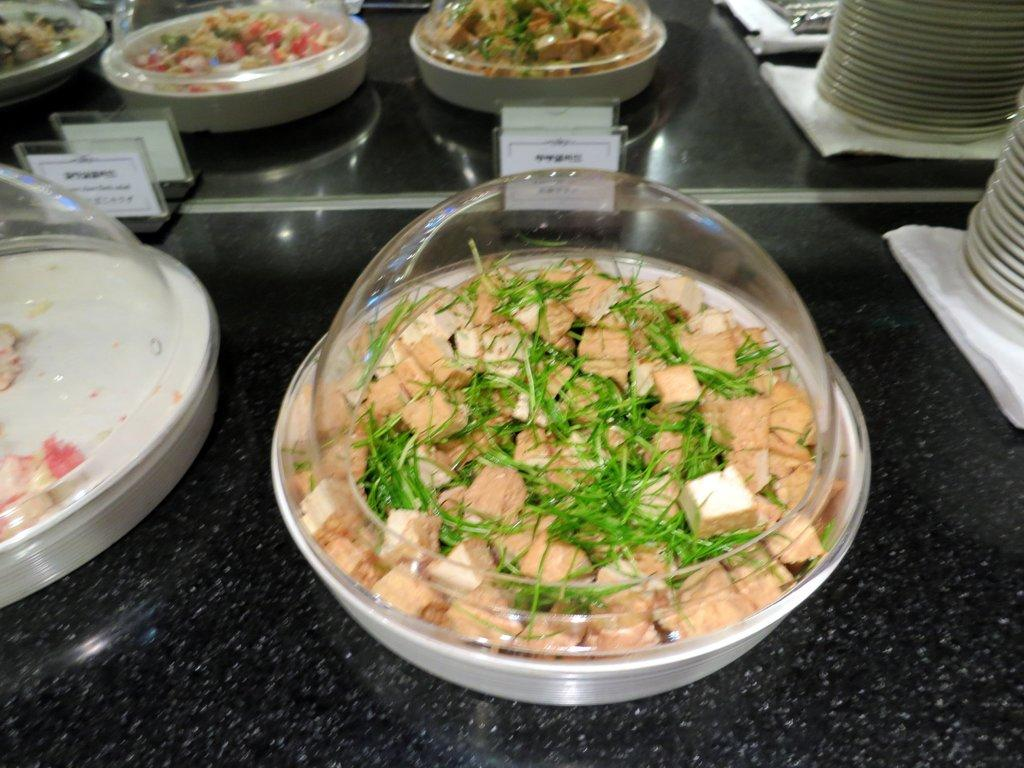What type of containers are holding food items in the image? There are bowls containing food items in the image. How are the bowls covered in the image? The bowls are covered with glass lids. What can be seen on the table in the image? There are plates on the table in the image. Are there any labels or identifiers for the food items in the image? Yes, there are name boards in the image. Can you tell me how many shirts are visible in the image? There are no shirts present in the image. Is there any quicksand in the image? There is no quicksand present in the image. 